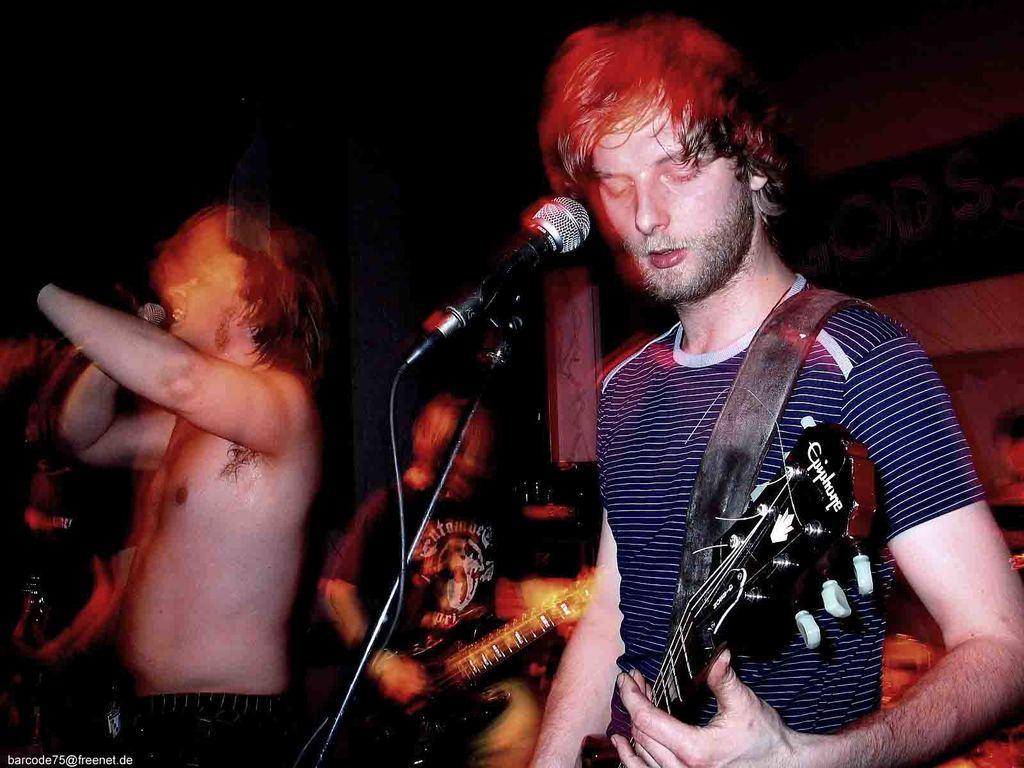Please provide a concise description of this image. Background is dark. Here we can see two persons playing guitar. This is amike. Here we can see a man holding and mike in his hand and singing. Its blurry. 